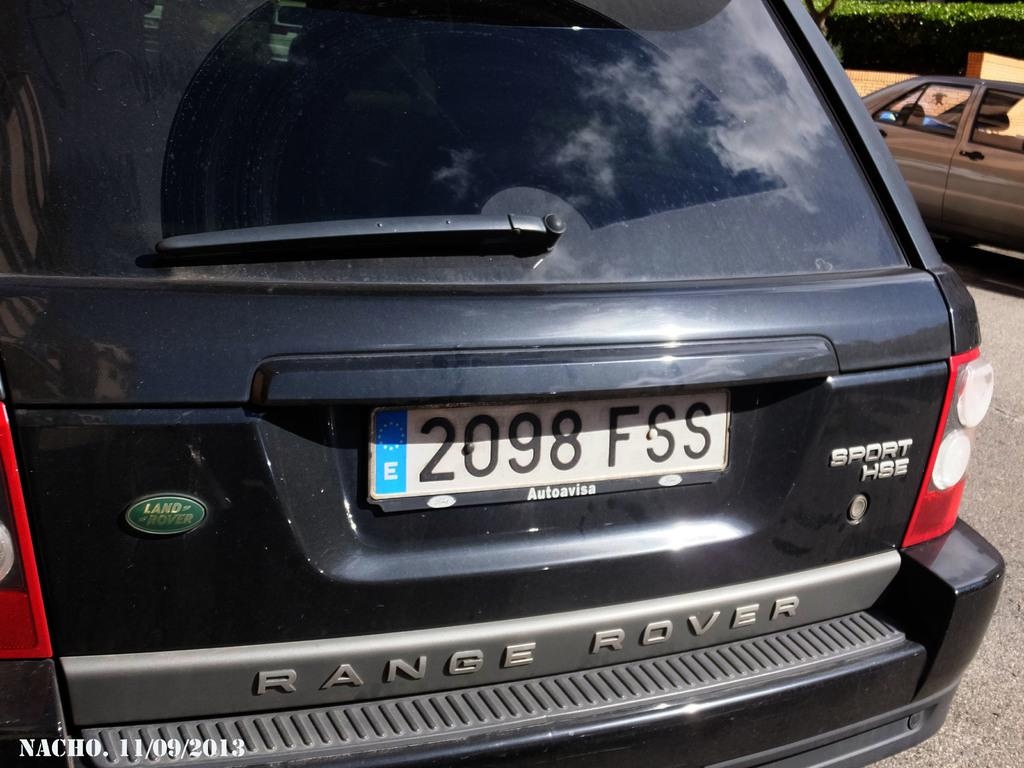<image>
Give a short and clear explanation of the subsequent image. The black car shown is a range rover made by land rover. 